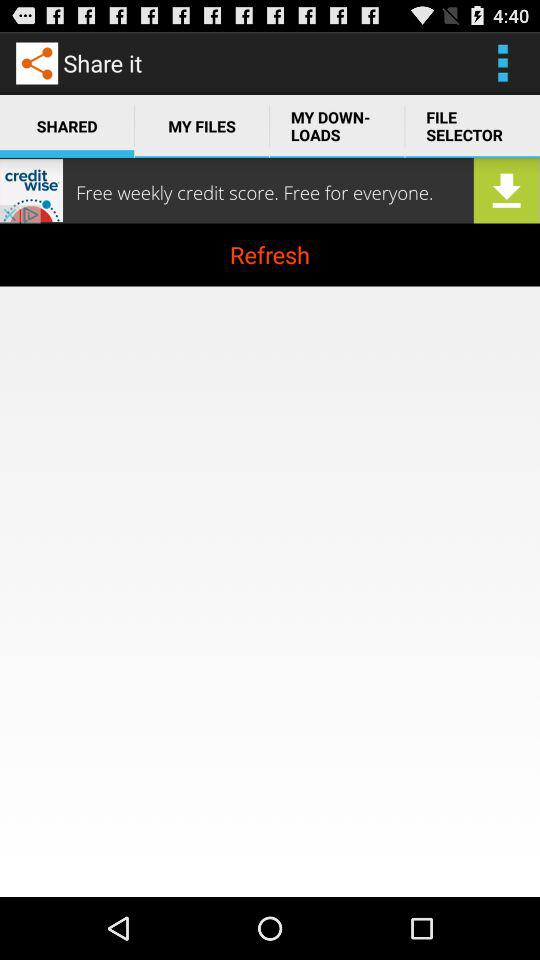What is the app name? The app name is "Share it". 